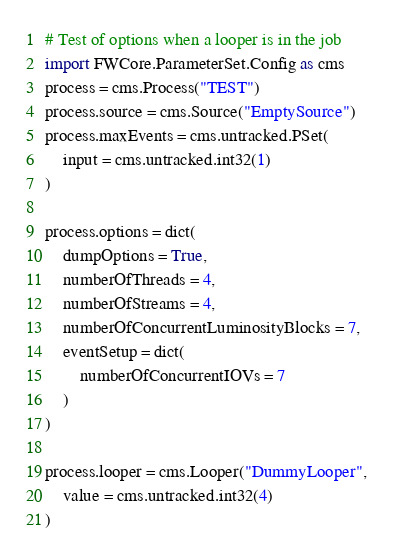Convert code to text. <code><loc_0><loc_0><loc_500><loc_500><_Python_># Test of options when a looper is in the job
import FWCore.ParameterSet.Config as cms
process = cms.Process("TEST")
process.source = cms.Source("EmptySource")
process.maxEvents = cms.untracked.PSet(
    input = cms.untracked.int32(1)
)

process.options = dict(
    dumpOptions = True,
    numberOfThreads = 4,
    numberOfStreams = 4,
    numberOfConcurrentLuminosityBlocks = 7,
    eventSetup = dict(
        numberOfConcurrentIOVs = 7
    )
)

process.looper = cms.Looper("DummyLooper",
    value = cms.untracked.int32(4)
)
</code> 